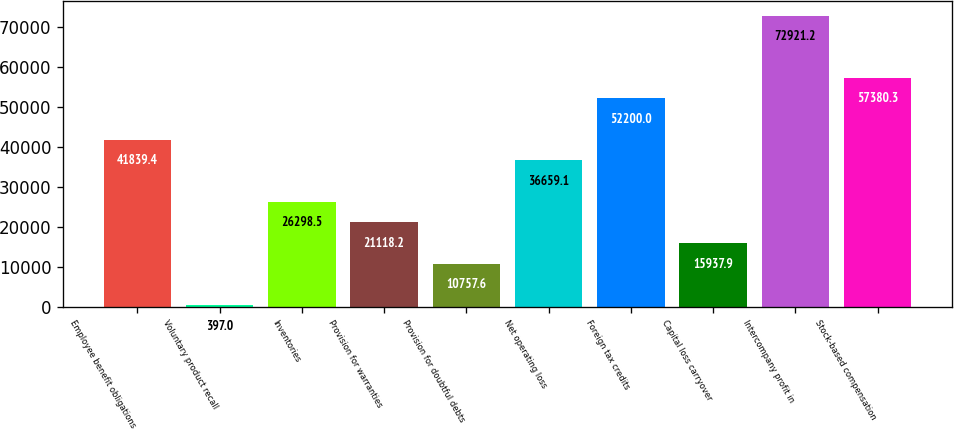Convert chart. <chart><loc_0><loc_0><loc_500><loc_500><bar_chart><fcel>Employee benefit obligations<fcel>Voluntary product recall<fcel>Inventories<fcel>Provision for warranties<fcel>Provision for doubtful debts<fcel>Net operating loss<fcel>Foreign tax credits<fcel>Capital loss carryover<fcel>Intercompany profit in<fcel>Stock-based compensation<nl><fcel>41839.4<fcel>397<fcel>26298.5<fcel>21118.2<fcel>10757.6<fcel>36659.1<fcel>52200<fcel>15937.9<fcel>72921.2<fcel>57380.3<nl></chart> 